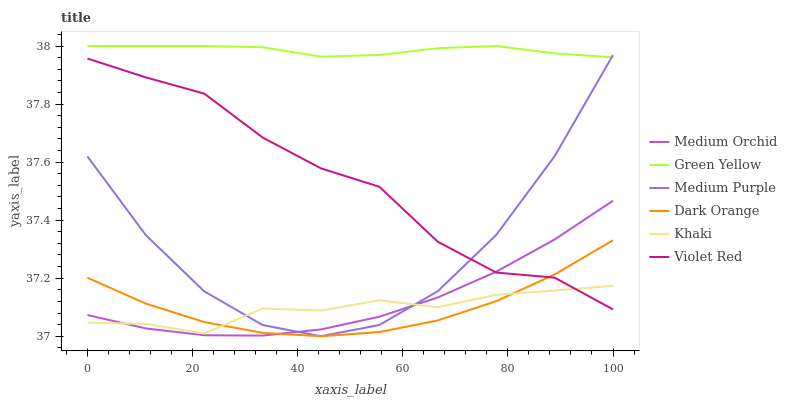Does Dark Orange have the minimum area under the curve?
Answer yes or no. Yes. Does Green Yellow have the maximum area under the curve?
Answer yes or no. Yes. Does Violet Red have the minimum area under the curve?
Answer yes or no. No. Does Violet Red have the maximum area under the curve?
Answer yes or no. No. Is Green Yellow the smoothest?
Answer yes or no. Yes. Is Medium Purple the roughest?
Answer yes or no. Yes. Is Violet Red the smoothest?
Answer yes or no. No. Is Violet Red the roughest?
Answer yes or no. No. Does Medium Purple have the lowest value?
Answer yes or no. Yes. Does Violet Red have the lowest value?
Answer yes or no. No. Does Green Yellow have the highest value?
Answer yes or no. Yes. Does Violet Red have the highest value?
Answer yes or no. No. Is Dark Orange less than Green Yellow?
Answer yes or no. Yes. Is Green Yellow greater than Violet Red?
Answer yes or no. Yes. Does Medium Purple intersect Dark Orange?
Answer yes or no. Yes. Is Medium Purple less than Dark Orange?
Answer yes or no. No. Is Medium Purple greater than Dark Orange?
Answer yes or no. No. Does Dark Orange intersect Green Yellow?
Answer yes or no. No. 